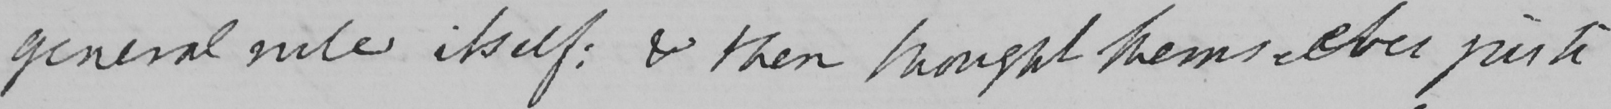What does this handwritten line say? general rule itself :  & then thought themselves justi 